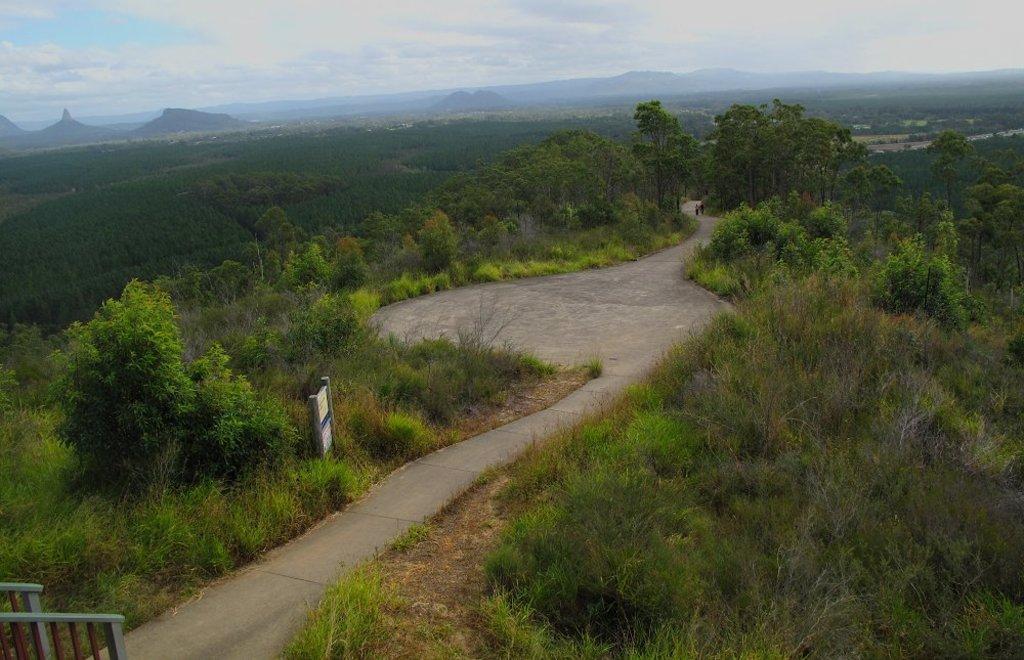In one or two sentences, can you explain what this image depicts? On the bottom left of the image there is a wooden gate, in front of the gate there is a pavement, on the pavement there are two people walking, besides the pavement there are plants, bushes, display board and trees, in the background of the image there are mountains, at the top of the image there are clouds in the sky. 